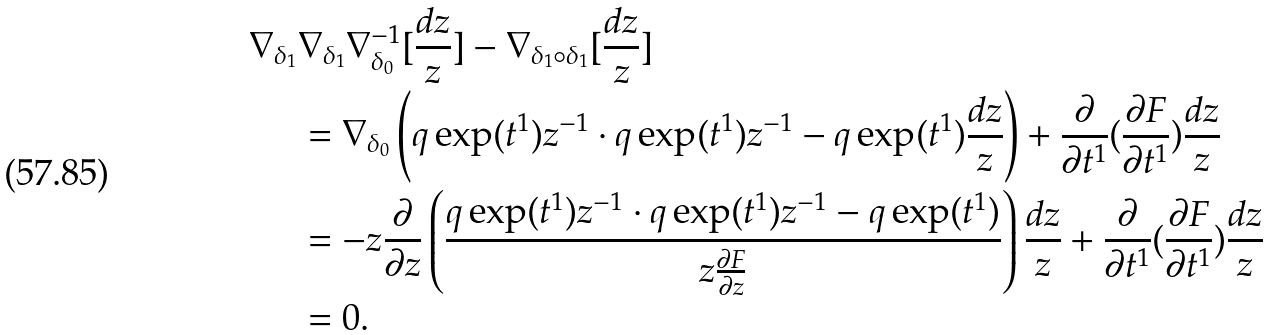Convert formula to latex. <formula><loc_0><loc_0><loc_500><loc_500>\nabla _ { \delta _ { 1 } } & \nabla _ { \delta _ { 1 } } \nabla _ { \delta _ { 0 } } ^ { - 1 } [ \frac { d z } { z } ] - \nabla _ { \delta _ { 1 } \circ \delta _ { 1 } } [ \frac { d z } { z } ] \\ & = \nabla _ { \delta _ { 0 } } \left ( q \exp ( t ^ { 1 } ) z ^ { - 1 } \cdot q \exp ( t ^ { 1 } ) z ^ { - 1 } - q \exp ( t ^ { 1 } ) \frac { d z } { z } \right ) + \frac { \partial } { \partial t ^ { 1 } } ( \frac { \partial F } { \partial t ^ { 1 } } ) \frac { d z } { z } \\ & = - z \frac { \partial } { \partial z } \left ( \frac { q \exp ( t ^ { 1 } ) z ^ { - 1 } \cdot q \exp ( t ^ { 1 } ) z ^ { - 1 } - q \exp ( t ^ { 1 } ) } { z \frac { \partial F } { \partial z } } \right ) \frac { d z } { z } + \frac { \partial } { \partial t ^ { 1 } } ( \frac { \partial F } { \partial t ^ { 1 } } ) \frac { d z } { z } \\ & = 0 .</formula> 